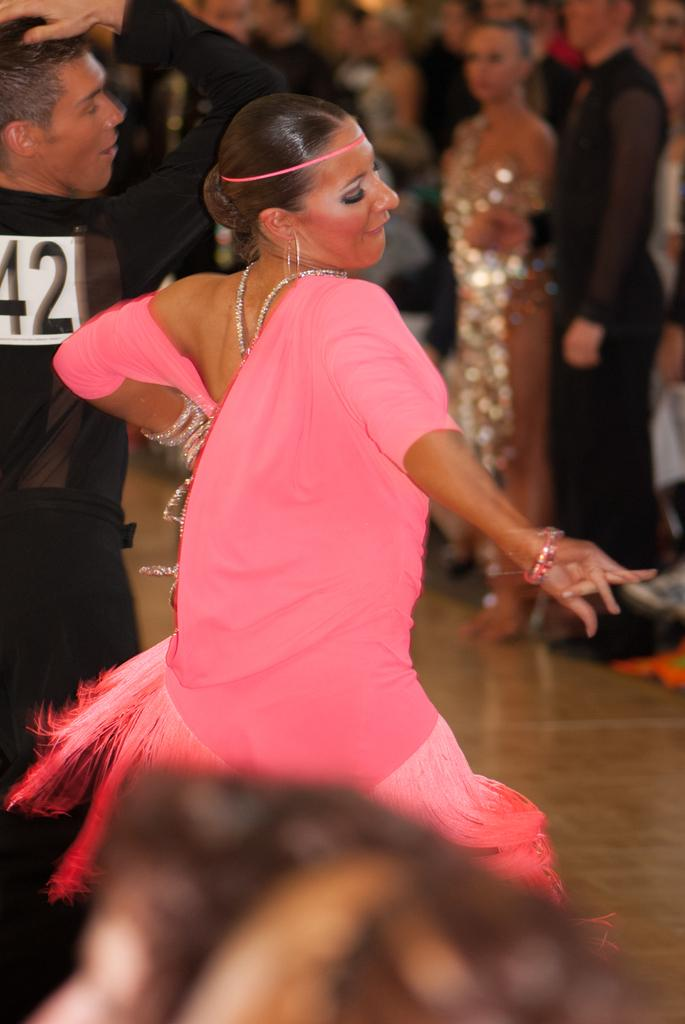Who can be seen in the image? There is a man and a woman in the image. What are the man and woman doing in the image? The man and woman are dancing. Can you describe the scene in the background of the image? There is a group of people in the background of the image. What type of dress is the man wearing on his voyage in the image? There is no mention of a voyage or a dress in the image; the man is dancing with a woman. 